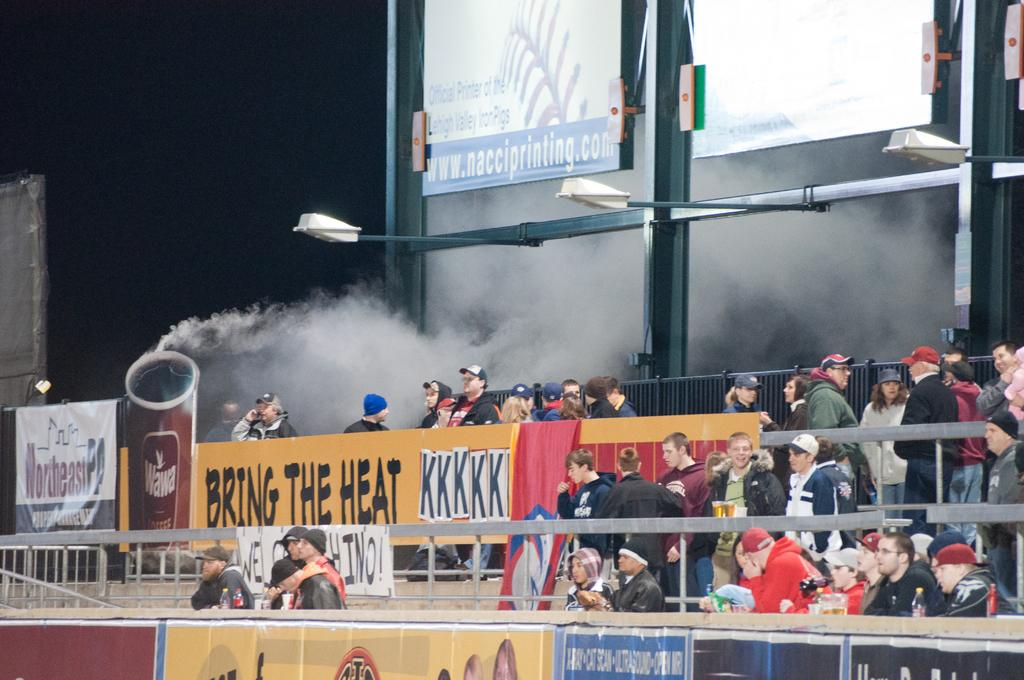What can be seen in the image that indicates some sort of activity or event? There are people standing in the image, which suggests that there is some activity or event taking place. What else is visible in the image besides the people? There is smoke in the image, which could be related to the activity or event. What street is the show being filmed on in the image? There is no mention of a show or a street in the image; it only shows people and smoke. 